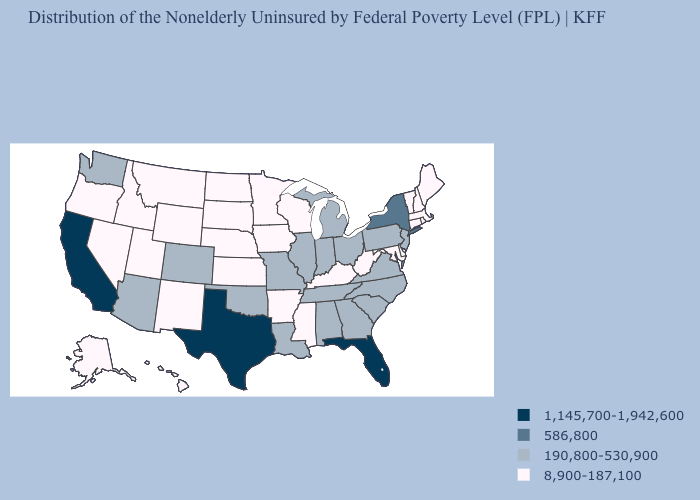Does Maine have the lowest value in the Northeast?
Keep it brief. Yes. Name the states that have a value in the range 586,800?
Keep it brief. New York. What is the highest value in the USA?
Be succinct. 1,145,700-1,942,600. Name the states that have a value in the range 190,800-530,900?
Give a very brief answer. Alabama, Arizona, Colorado, Georgia, Illinois, Indiana, Louisiana, Michigan, Missouri, New Jersey, North Carolina, Ohio, Oklahoma, Pennsylvania, South Carolina, Tennessee, Virginia, Washington. Name the states that have a value in the range 8,900-187,100?
Answer briefly. Alaska, Arkansas, Connecticut, Delaware, Hawaii, Idaho, Iowa, Kansas, Kentucky, Maine, Maryland, Massachusetts, Minnesota, Mississippi, Montana, Nebraska, Nevada, New Hampshire, New Mexico, North Dakota, Oregon, Rhode Island, South Dakota, Utah, Vermont, West Virginia, Wisconsin, Wyoming. What is the highest value in the USA?
Be succinct. 1,145,700-1,942,600. What is the value of New York?
Quick response, please. 586,800. Does West Virginia have a lower value than Alaska?
Write a very short answer. No. What is the lowest value in states that border Iowa?
Concise answer only. 8,900-187,100. Name the states that have a value in the range 586,800?
Keep it brief. New York. Name the states that have a value in the range 586,800?
Short answer required. New York. What is the value of Texas?
Concise answer only. 1,145,700-1,942,600. Among the states that border Pennsylvania , does Maryland have the highest value?
Answer briefly. No. Is the legend a continuous bar?
Keep it brief. No. 